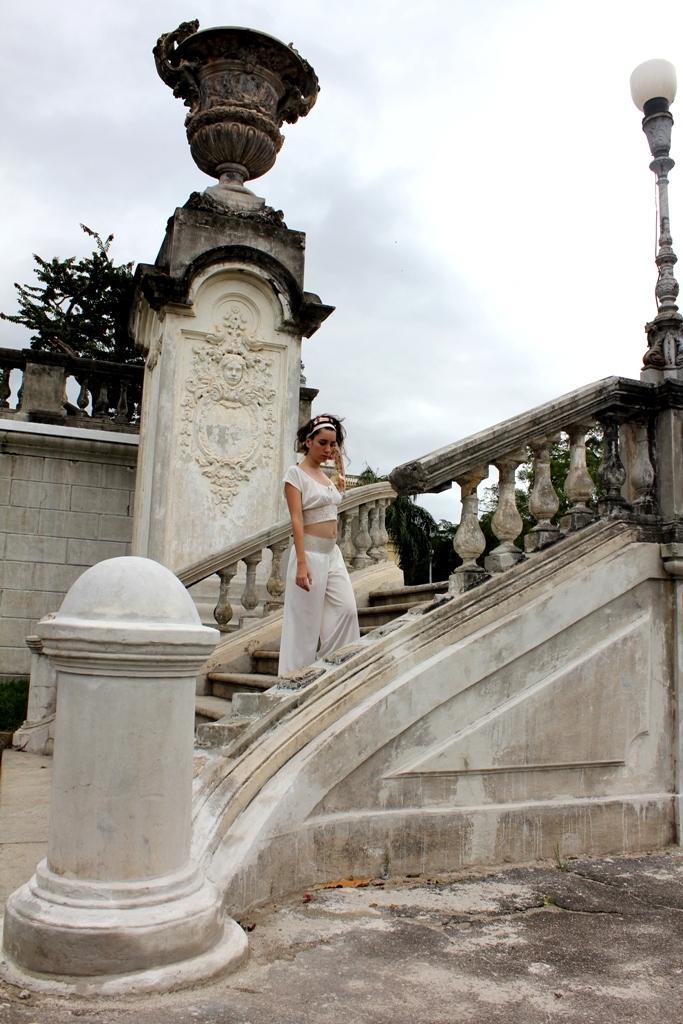In one or two sentences, can you explain what this image depicts? In this picture we can see a woman, she wore a white color dress, beside to her we can see a pole and a light, in the background we can find few trees and clouds. 